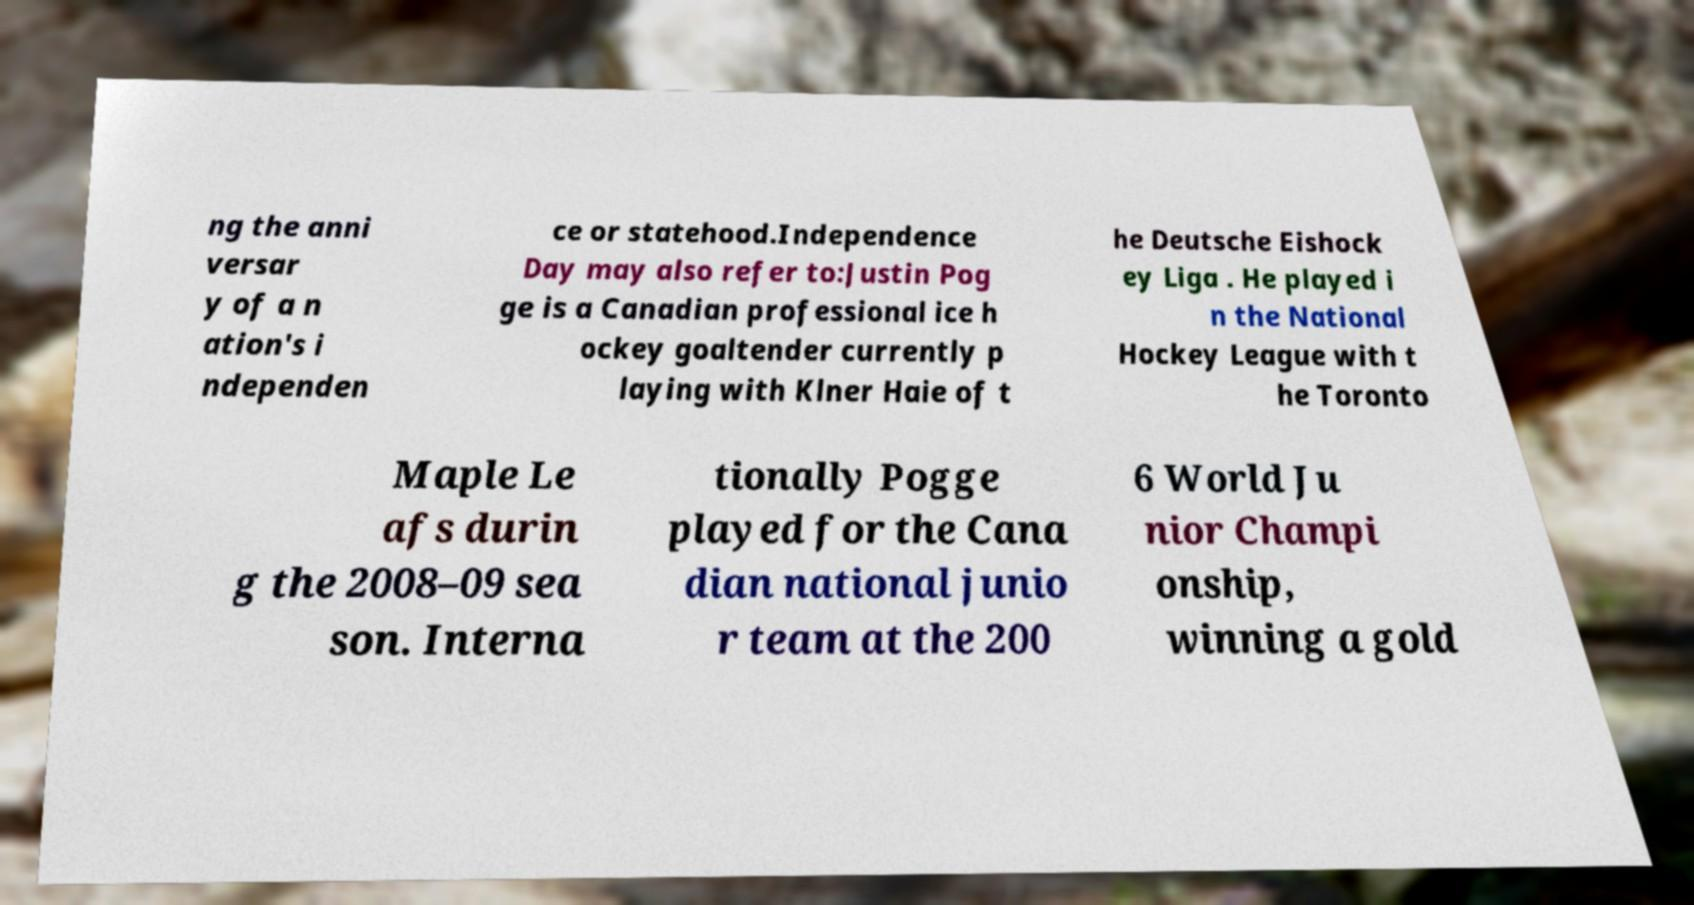Can you read and provide the text displayed in the image?This photo seems to have some interesting text. Can you extract and type it out for me? ng the anni versar y of a n ation's i ndependen ce or statehood.Independence Day may also refer to:Justin Pog ge is a Canadian professional ice h ockey goaltender currently p laying with Klner Haie of t he Deutsche Eishock ey Liga . He played i n the National Hockey League with t he Toronto Maple Le afs durin g the 2008–09 sea son. Interna tionally Pogge played for the Cana dian national junio r team at the 200 6 World Ju nior Champi onship, winning a gold 